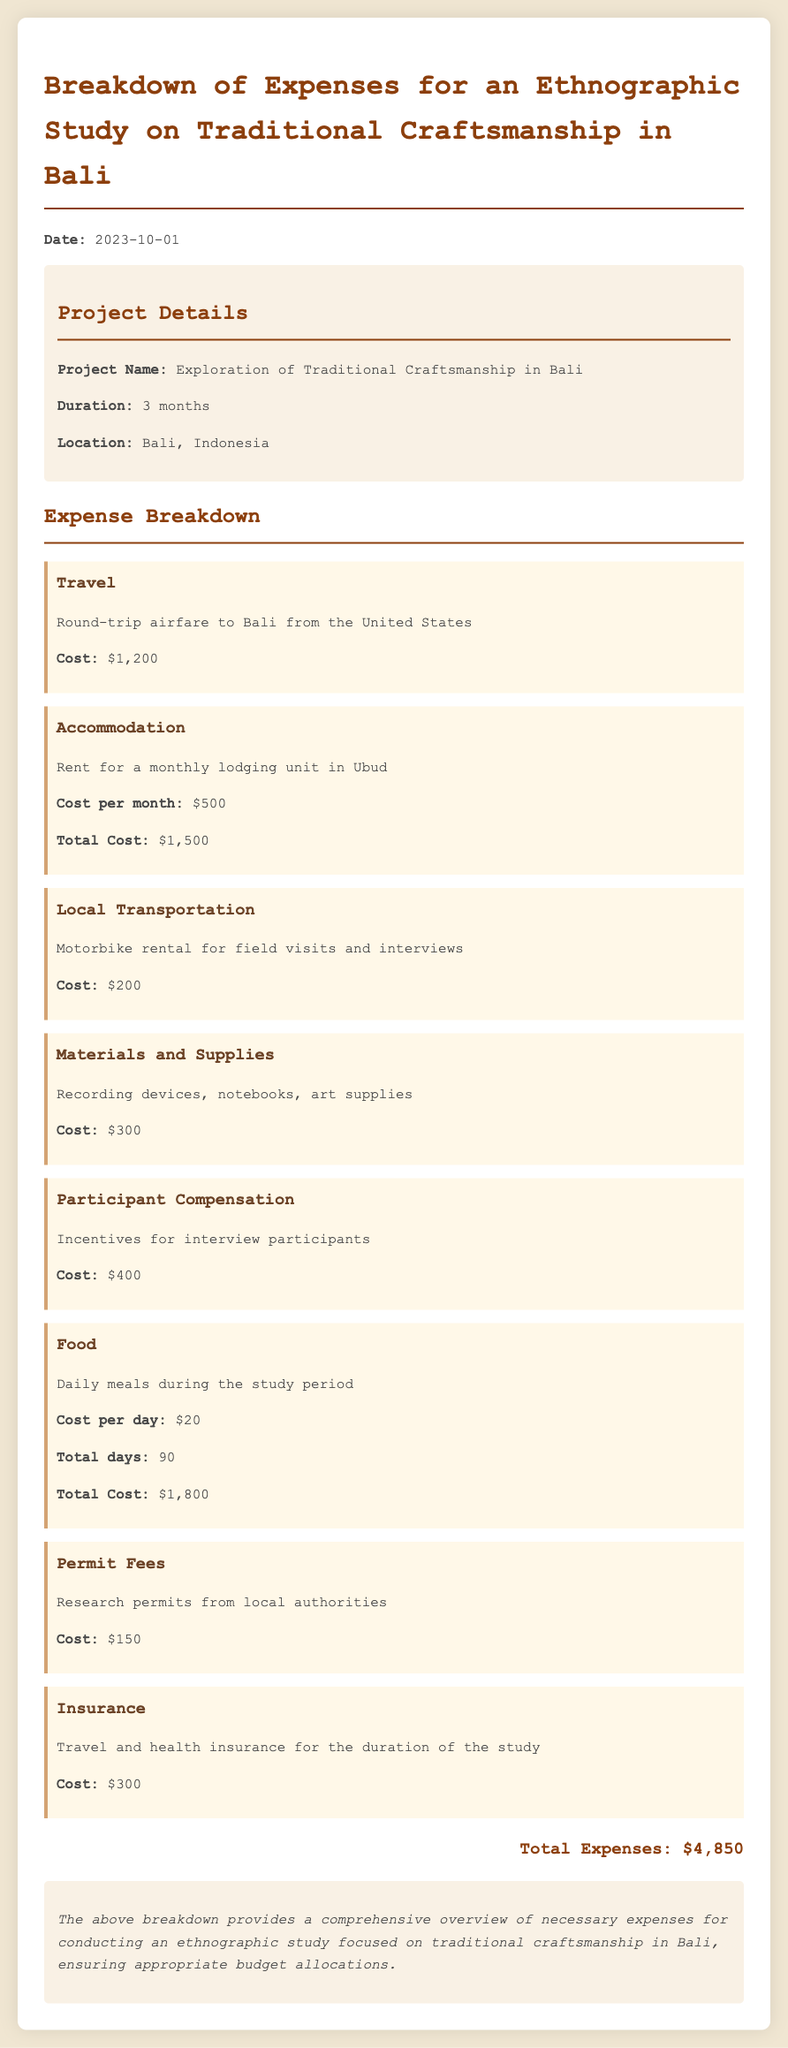What is the total cost of accommodation? The total cost of accommodation is listed as $1,500, which is the rent for three months in Ubud at $500 per month.
Answer: $1,500 What is the cost of participant compensation? The document specifies that participant compensation incentives amount to $400.
Answer: $400 How much is the travel expense? The travel expense for round-trip airfare to Bali is stated as $1,200.
Answer: $1,200 What is the daily cost for food? The document indicates the daily cost for food is $20.
Answer: $20 What is the total duration of the project? The project duration is mentioned as 3 months in the project details.
Answer: 3 months What is the total number of days for food expenses? The total number of days for food expenses during the study period is calculated to be 90 days.
Answer: 90 Which locale is the project being conducted in? The project is being conducted in Bali, Indonesia, according to the project details.
Answer: Bali, Indonesia What is the total amount of recorded expenses? The document sums the total expenses listed, which equals $4,850.
Answer: $4,850 What type of report is this document? The document is categorized as a financial report detailing expense breakdowns for an ethnographic study.
Answer: financial report 